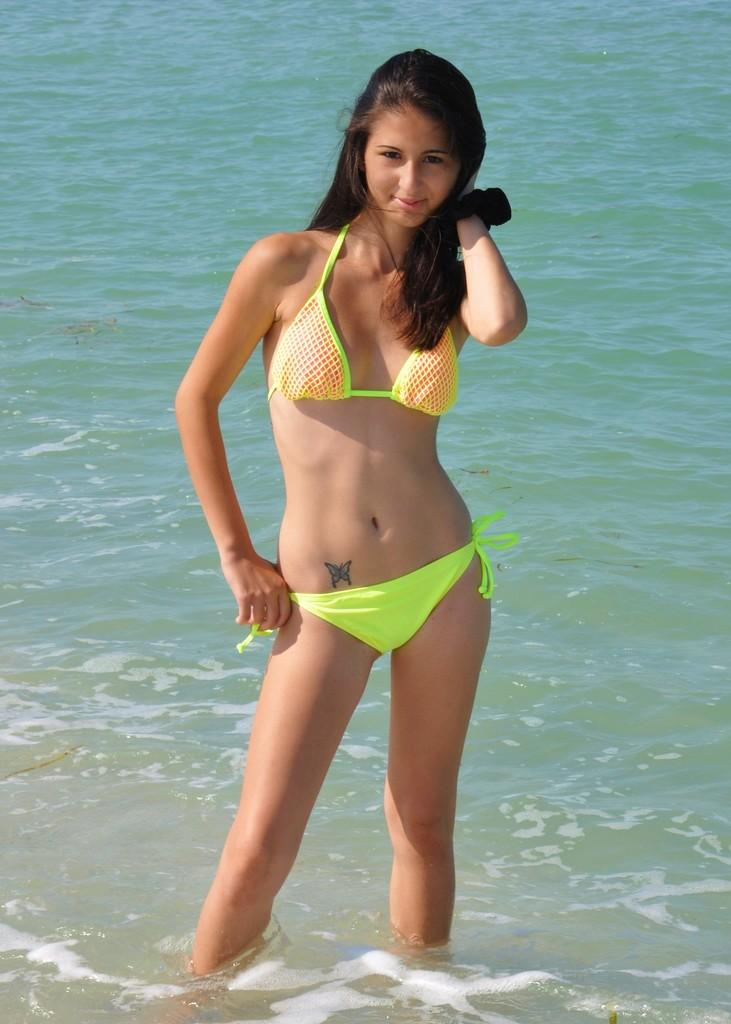Who is present in the image? There is a girl in the image. What is the girl's expression? The girl is smiling. What can be seen in the background of the image? There is water visible in the background of the image. What type of tin can be seen in the girl's hand in the image? There is no tin present in the image. How many zippers are visible on the girl's clothing in the image? There are no zippers visible on the girl's clothing in the image. 